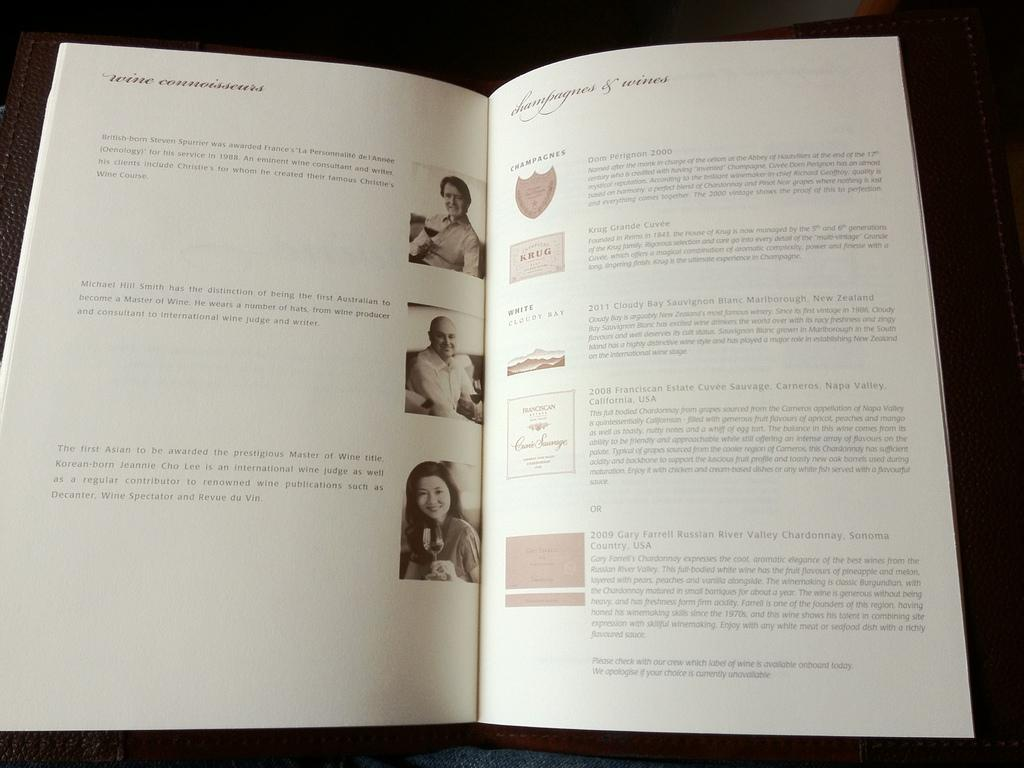<image>
Describe the image concisely. A booklet lays open with the right page listing champagnes and wines. 